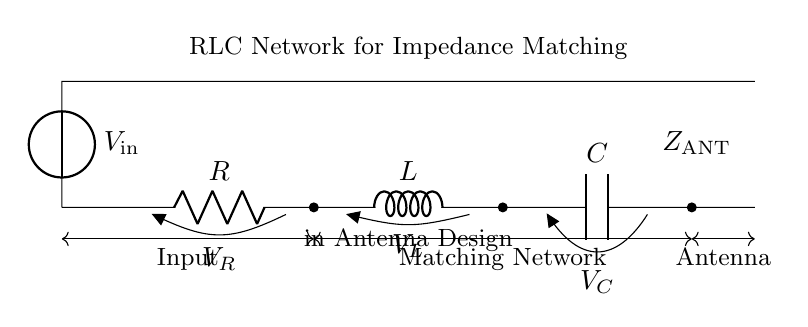What components are present in this circuit? The circuit diagram displays three primary components: a resistor, an inductor, and a capacitor, which are labeled as R, L, and C respectively.
Answer: Resistor, Inductor, Capacitor What is the role of the RLC network in this circuit? The RLC network is specifically designed for impedance matching, allowing efficient power transfer between the input and the antenna by matching their impedances.
Answer: Impedance matching What does "Z_ANT" represent in this circuit? "Z_ANT" denotes the impedance of the antenna, which is a critical factor in effective antenna design and operation.
Answer: Impedance of the antenna How many branches are there in this circuit? The circuit has a single branch that includes all three components, connected in series from the voltage source to the antenna.
Answer: One branch If the input voltage is 10 volts, what is the voltage across the inductor? The voltage across the inductor can vary depending on the current through it and its inductance; it can't be specified without further measurements or values in the circuit.
Answer: Cannot be determined What effect does varying the resistance have on the matching network's performance? Increasing resistance may improve the circuit's stability and bandwidth, while decreasing resistance may lead to better impedance matching but can also increase losses.
Answer: Varies performance Why is a matching network necessary in antenna design? A matching network is vital to compensate for impedance differences, which minimizes reflection and maximizes power transfer from the source to the antenna.
Answer: Minimizes reflection, maximizes power transfer 